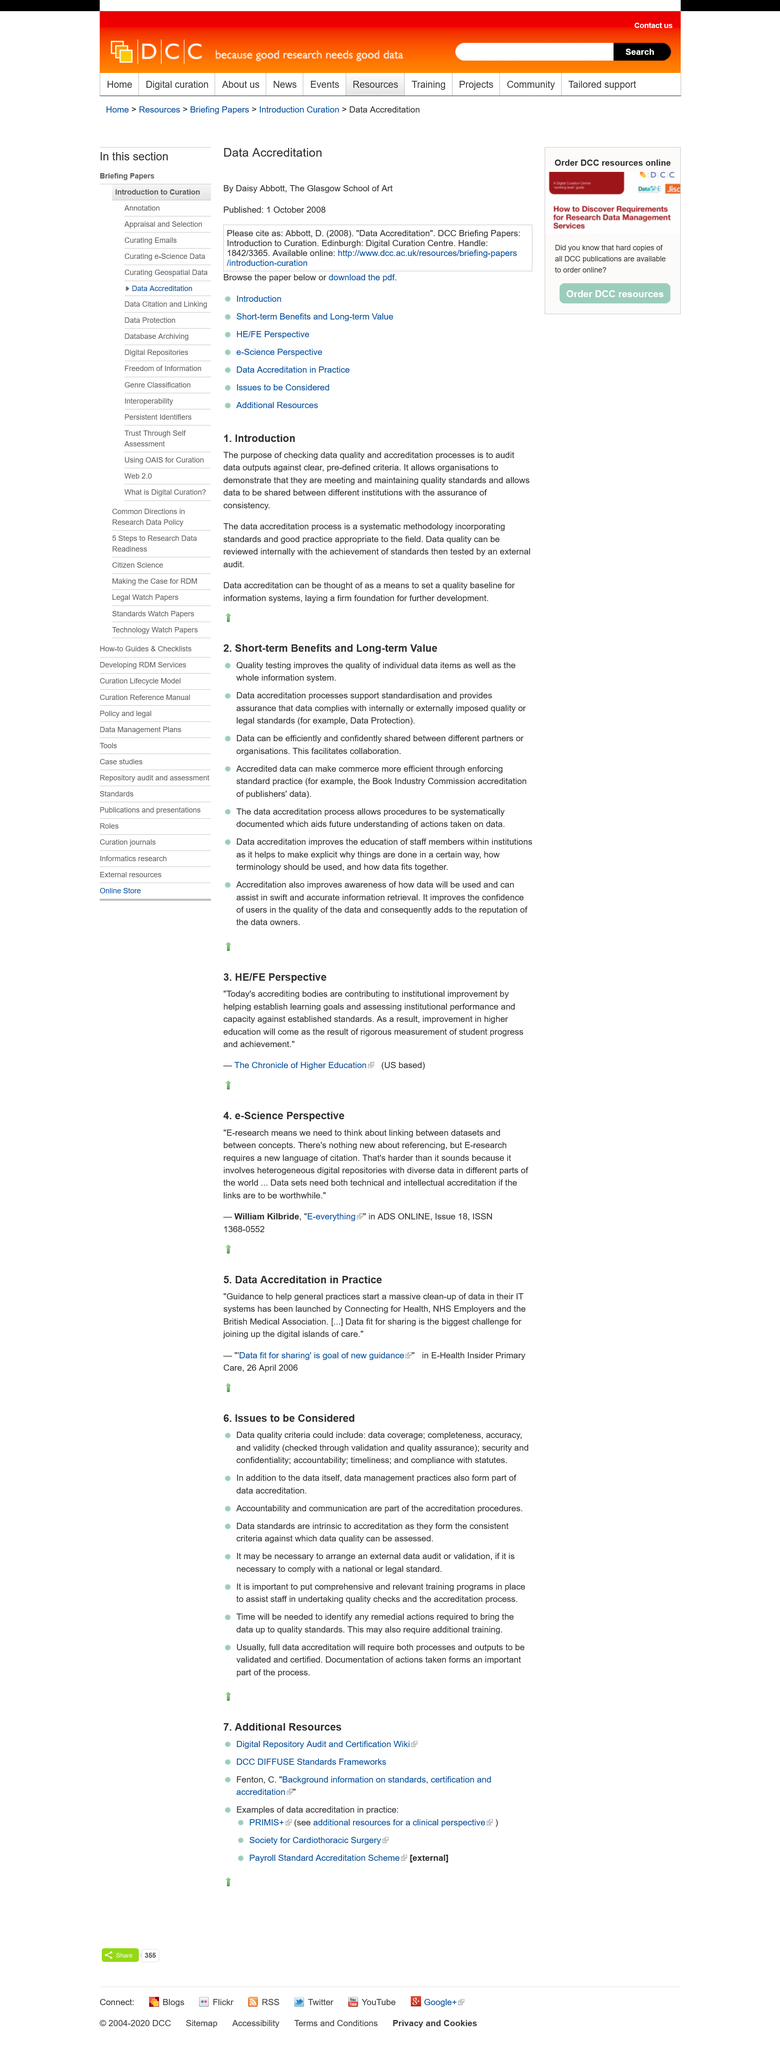Outline some significant characteristics in this image. The article "1. Introduction" states that the purpose of checking data quality and accreditation processes is to audit data outputs against clear, pre-defined criteria. Organizations can demonstrate that they are meeting quality standards by verifying the accuracy and completeness of their data through quality assurance processes and obtaining relevant accreditation. The review of data quality is conducted both internally and externally, with the achievement of established standards serving as a basis for evaluation, and an external audit to verify the accuracy and reliability of the data. 